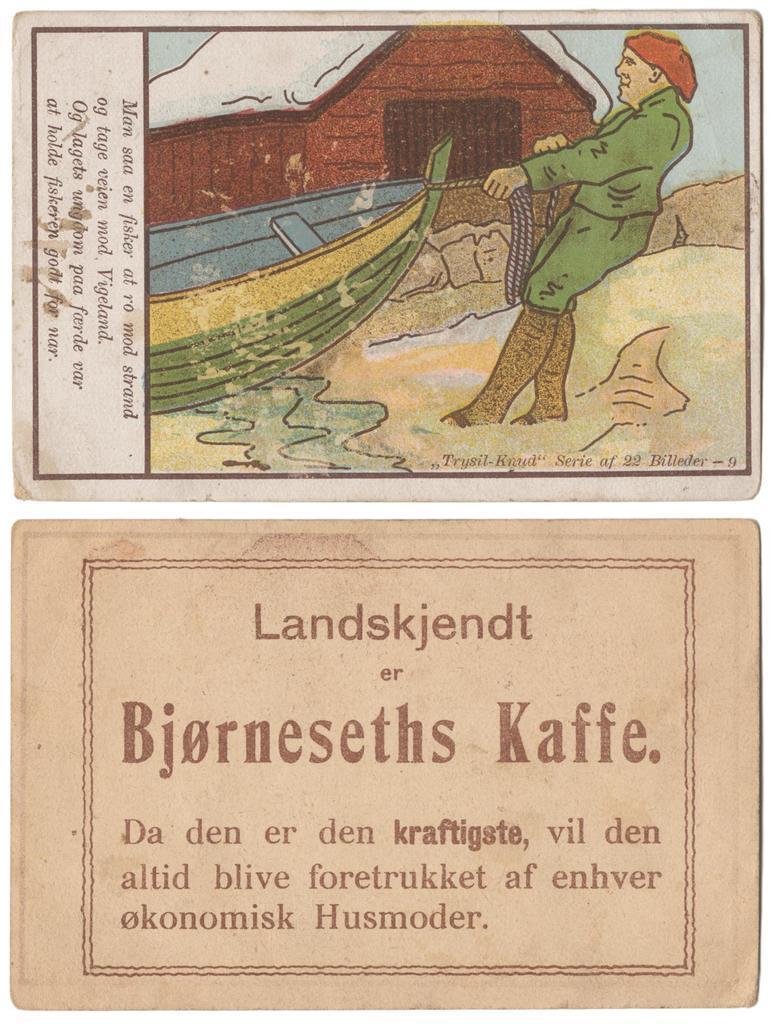In one or two sentences, can you explain what this image depicts? In this image at the bottom there is a board, on the board there is text. At the top of the image there is one paper and on the paper there is text and one person, house, water and sand. 